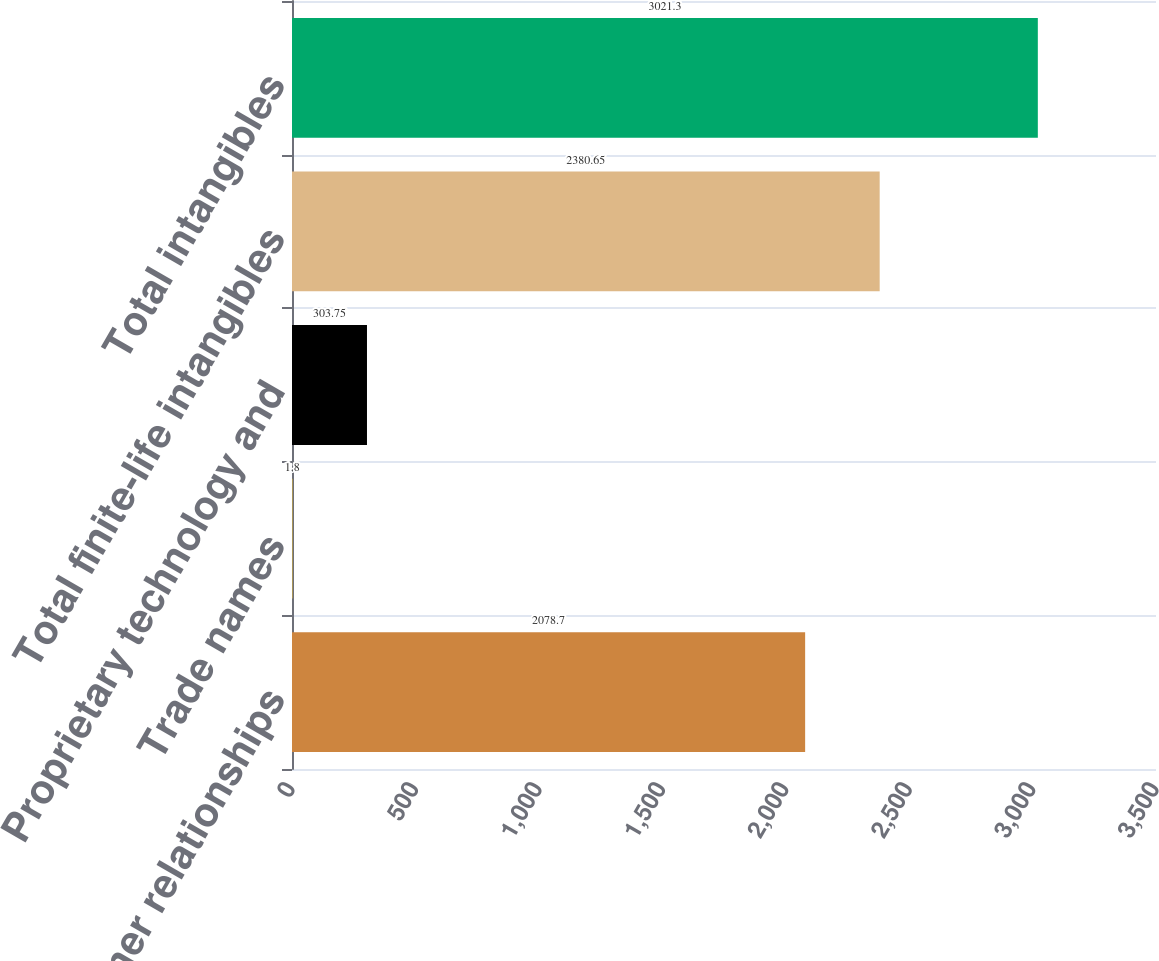Convert chart. <chart><loc_0><loc_0><loc_500><loc_500><bar_chart><fcel>Customer relationships<fcel>Trade names<fcel>Proprietary technology and<fcel>Total finite-life intangibles<fcel>Total intangibles<nl><fcel>2078.7<fcel>1.8<fcel>303.75<fcel>2380.65<fcel>3021.3<nl></chart> 